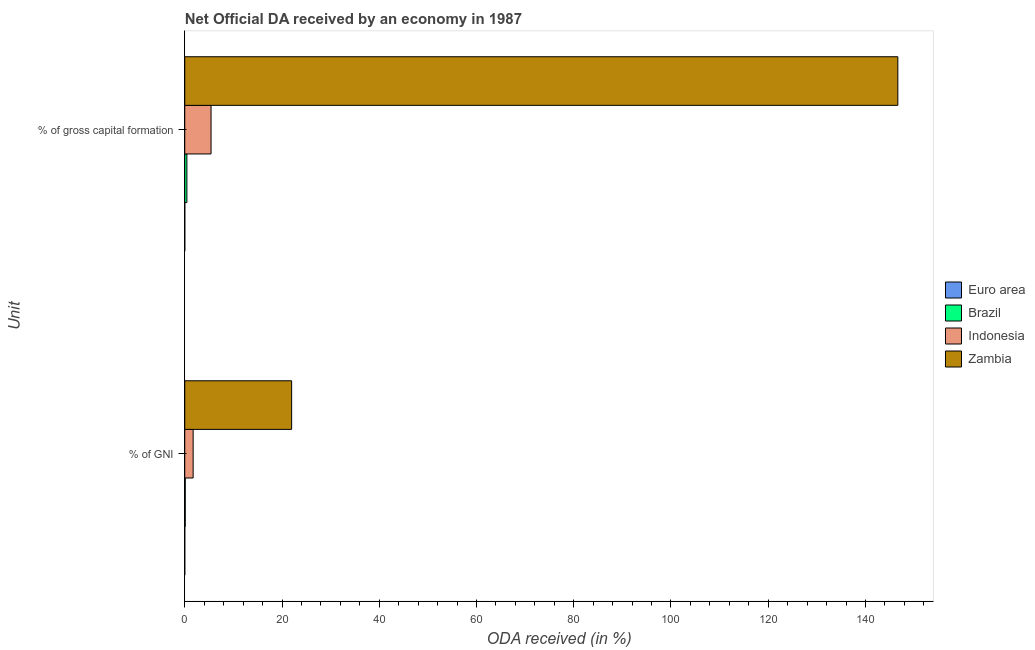Are the number of bars per tick equal to the number of legend labels?
Your response must be concise. Yes. Are the number of bars on each tick of the Y-axis equal?
Provide a short and direct response. Yes. What is the label of the 2nd group of bars from the top?
Offer a very short reply. % of GNI. What is the oda received as percentage of gross capital formation in Indonesia?
Your response must be concise. 5.41. Across all countries, what is the maximum oda received as percentage of gni?
Offer a terse response. 21.98. Across all countries, what is the minimum oda received as percentage of gni?
Provide a short and direct response. 0. In which country was the oda received as percentage of gross capital formation maximum?
Provide a succinct answer. Zambia. In which country was the oda received as percentage of gni minimum?
Your answer should be very brief. Euro area. What is the total oda received as percentage of gross capital formation in the graph?
Make the answer very short. 152.51. What is the difference between the oda received as percentage of gni in Indonesia and that in Zambia?
Keep it short and to the point. -20.26. What is the difference between the oda received as percentage of gni in Euro area and the oda received as percentage of gross capital formation in Indonesia?
Your answer should be compact. -5.41. What is the average oda received as percentage of gni per country?
Keep it short and to the point. 5.95. What is the difference between the oda received as percentage of gni and oda received as percentage of gross capital formation in Indonesia?
Your answer should be compact. -3.68. What is the ratio of the oda received as percentage of gross capital formation in Euro area to that in Indonesia?
Your answer should be very brief. 0. Is the oda received as percentage of gni in Zambia less than that in Indonesia?
Ensure brevity in your answer.  No. In how many countries, is the oda received as percentage of gross capital formation greater than the average oda received as percentage of gross capital formation taken over all countries?
Your answer should be compact. 1. What does the 4th bar from the bottom in % of gross capital formation represents?
Ensure brevity in your answer.  Zambia. What is the difference between two consecutive major ticks on the X-axis?
Your response must be concise. 20. Are the values on the major ticks of X-axis written in scientific E-notation?
Your answer should be very brief. No. Does the graph contain any zero values?
Keep it short and to the point. No. Does the graph contain grids?
Offer a terse response. No. Where does the legend appear in the graph?
Ensure brevity in your answer.  Center right. How many legend labels are there?
Provide a succinct answer. 4. How are the legend labels stacked?
Your response must be concise. Vertical. What is the title of the graph?
Ensure brevity in your answer.  Net Official DA received by an economy in 1987. What is the label or title of the X-axis?
Give a very brief answer. ODA received (in %). What is the label or title of the Y-axis?
Give a very brief answer. Unit. What is the ODA received (in %) in Euro area in % of GNI?
Give a very brief answer. 0. What is the ODA received (in %) of Brazil in % of GNI?
Keep it short and to the point. 0.1. What is the ODA received (in %) in Indonesia in % of GNI?
Make the answer very short. 1.72. What is the ODA received (in %) of Zambia in % of GNI?
Provide a short and direct response. 21.98. What is the ODA received (in %) in Euro area in % of gross capital formation?
Make the answer very short. 0. What is the ODA received (in %) in Brazil in % of gross capital formation?
Your response must be concise. 0.44. What is the ODA received (in %) of Indonesia in % of gross capital formation?
Make the answer very short. 5.41. What is the ODA received (in %) in Zambia in % of gross capital formation?
Offer a terse response. 146.66. Across all Unit, what is the maximum ODA received (in %) of Euro area?
Your answer should be compact. 0. Across all Unit, what is the maximum ODA received (in %) in Brazil?
Give a very brief answer. 0.44. Across all Unit, what is the maximum ODA received (in %) of Indonesia?
Provide a short and direct response. 5.41. Across all Unit, what is the maximum ODA received (in %) in Zambia?
Provide a succinct answer. 146.66. Across all Unit, what is the minimum ODA received (in %) of Euro area?
Provide a succinct answer. 0. Across all Unit, what is the minimum ODA received (in %) of Brazil?
Give a very brief answer. 0.1. Across all Unit, what is the minimum ODA received (in %) in Indonesia?
Your response must be concise. 1.72. Across all Unit, what is the minimum ODA received (in %) in Zambia?
Your answer should be very brief. 21.98. What is the total ODA received (in %) in Euro area in the graph?
Provide a succinct answer. 0.01. What is the total ODA received (in %) in Brazil in the graph?
Offer a very short reply. 0.54. What is the total ODA received (in %) of Indonesia in the graph?
Ensure brevity in your answer.  7.13. What is the total ODA received (in %) in Zambia in the graph?
Provide a short and direct response. 168.64. What is the difference between the ODA received (in %) in Euro area in % of GNI and that in % of gross capital formation?
Give a very brief answer. -0. What is the difference between the ODA received (in %) in Brazil in % of GNI and that in % of gross capital formation?
Your answer should be very brief. -0.34. What is the difference between the ODA received (in %) of Indonesia in % of GNI and that in % of gross capital formation?
Provide a succinct answer. -3.68. What is the difference between the ODA received (in %) of Zambia in % of GNI and that in % of gross capital formation?
Make the answer very short. -124.67. What is the difference between the ODA received (in %) of Euro area in % of GNI and the ODA received (in %) of Brazil in % of gross capital formation?
Your response must be concise. -0.44. What is the difference between the ODA received (in %) in Euro area in % of GNI and the ODA received (in %) in Indonesia in % of gross capital formation?
Provide a succinct answer. -5.41. What is the difference between the ODA received (in %) in Euro area in % of GNI and the ODA received (in %) in Zambia in % of gross capital formation?
Your answer should be compact. -146.66. What is the difference between the ODA received (in %) in Brazil in % of GNI and the ODA received (in %) in Indonesia in % of gross capital formation?
Provide a short and direct response. -5.3. What is the difference between the ODA received (in %) of Brazil in % of GNI and the ODA received (in %) of Zambia in % of gross capital formation?
Your response must be concise. -146.55. What is the difference between the ODA received (in %) in Indonesia in % of GNI and the ODA received (in %) in Zambia in % of gross capital formation?
Provide a short and direct response. -144.93. What is the average ODA received (in %) in Euro area per Unit?
Ensure brevity in your answer.  0. What is the average ODA received (in %) in Brazil per Unit?
Make the answer very short. 0.27. What is the average ODA received (in %) in Indonesia per Unit?
Your answer should be compact. 3.57. What is the average ODA received (in %) in Zambia per Unit?
Your answer should be very brief. 84.32. What is the difference between the ODA received (in %) in Euro area and ODA received (in %) in Brazil in % of GNI?
Your response must be concise. -0.1. What is the difference between the ODA received (in %) of Euro area and ODA received (in %) of Indonesia in % of GNI?
Offer a terse response. -1.72. What is the difference between the ODA received (in %) of Euro area and ODA received (in %) of Zambia in % of GNI?
Your response must be concise. -21.98. What is the difference between the ODA received (in %) of Brazil and ODA received (in %) of Indonesia in % of GNI?
Offer a terse response. -1.62. What is the difference between the ODA received (in %) of Brazil and ODA received (in %) of Zambia in % of GNI?
Your response must be concise. -21.88. What is the difference between the ODA received (in %) of Indonesia and ODA received (in %) of Zambia in % of GNI?
Give a very brief answer. -20.26. What is the difference between the ODA received (in %) of Euro area and ODA received (in %) of Brazil in % of gross capital formation?
Ensure brevity in your answer.  -0.43. What is the difference between the ODA received (in %) of Euro area and ODA received (in %) of Indonesia in % of gross capital formation?
Ensure brevity in your answer.  -5.4. What is the difference between the ODA received (in %) in Euro area and ODA received (in %) in Zambia in % of gross capital formation?
Offer a terse response. -146.65. What is the difference between the ODA received (in %) of Brazil and ODA received (in %) of Indonesia in % of gross capital formation?
Give a very brief answer. -4.97. What is the difference between the ODA received (in %) in Brazil and ODA received (in %) in Zambia in % of gross capital formation?
Ensure brevity in your answer.  -146.22. What is the difference between the ODA received (in %) in Indonesia and ODA received (in %) in Zambia in % of gross capital formation?
Provide a succinct answer. -141.25. What is the ratio of the ODA received (in %) in Euro area in % of GNI to that in % of gross capital formation?
Offer a very short reply. 0.22. What is the ratio of the ODA received (in %) of Brazil in % of GNI to that in % of gross capital formation?
Your answer should be compact. 0.23. What is the ratio of the ODA received (in %) in Indonesia in % of GNI to that in % of gross capital formation?
Your answer should be compact. 0.32. What is the ratio of the ODA received (in %) in Zambia in % of GNI to that in % of gross capital formation?
Keep it short and to the point. 0.15. What is the difference between the highest and the second highest ODA received (in %) in Euro area?
Ensure brevity in your answer.  0. What is the difference between the highest and the second highest ODA received (in %) of Brazil?
Provide a succinct answer. 0.34. What is the difference between the highest and the second highest ODA received (in %) in Indonesia?
Your response must be concise. 3.68. What is the difference between the highest and the second highest ODA received (in %) of Zambia?
Your answer should be very brief. 124.67. What is the difference between the highest and the lowest ODA received (in %) of Euro area?
Keep it short and to the point. 0. What is the difference between the highest and the lowest ODA received (in %) in Brazil?
Offer a very short reply. 0.34. What is the difference between the highest and the lowest ODA received (in %) of Indonesia?
Provide a succinct answer. 3.68. What is the difference between the highest and the lowest ODA received (in %) of Zambia?
Your response must be concise. 124.67. 